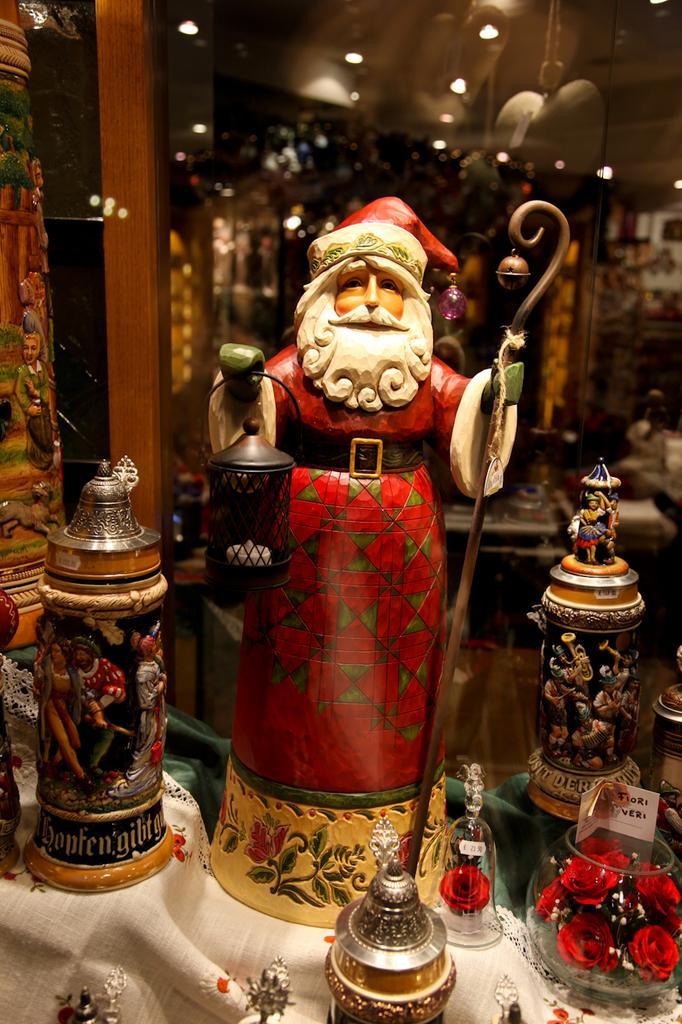Please provide a concise description of this image. In this picture in the middle, we can see a toy which is holding something in both hands. On the right side and left side, we can see some jars. In the background, we can also see glass door. On the top, we can see a roof with few lights. 